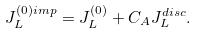<formula> <loc_0><loc_0><loc_500><loc_500>J _ { L } ^ { ( 0 ) i m p } = J _ { L } ^ { ( 0 ) } + C _ { A } J _ { L } ^ { d i s c } .</formula> 